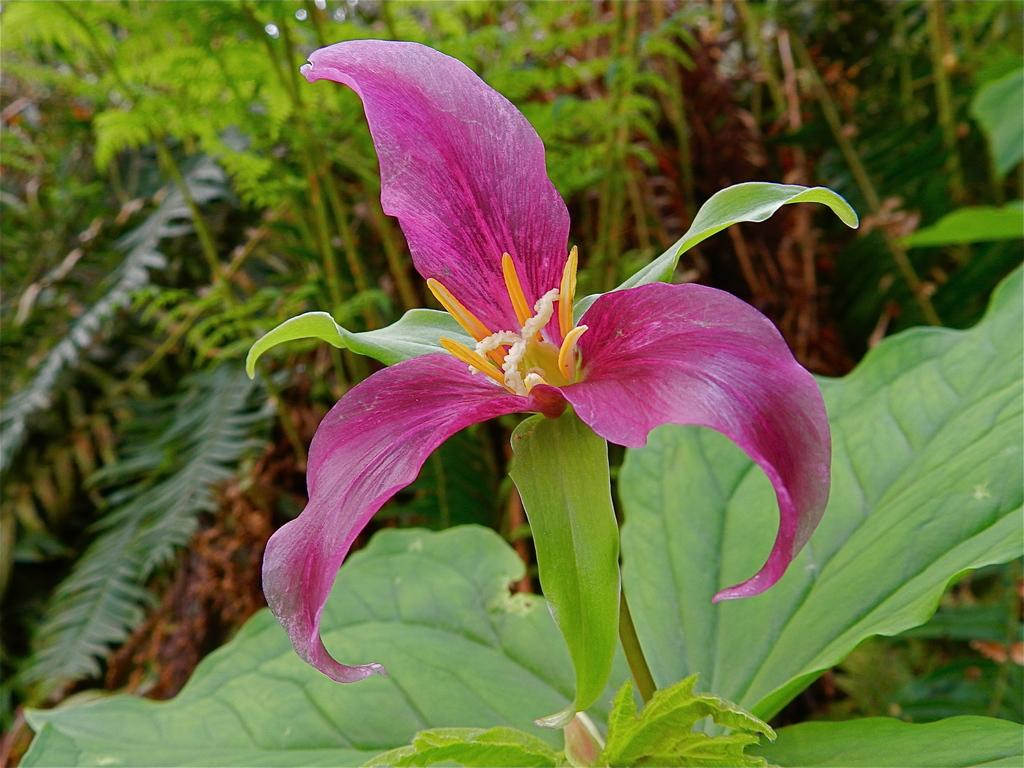What type of plant can be seen in the image? There is a flower with a stem in the image. Are there any other plants visible in the image? Yes, there are plants in the image. What type of ball is being used by the governor in the image? There is no ball or governor present in the image; it features a flower with a stem and other plants. 